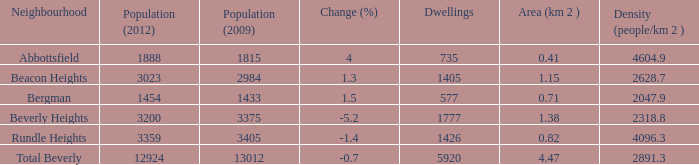What is the population density of a region that is 0.0. 